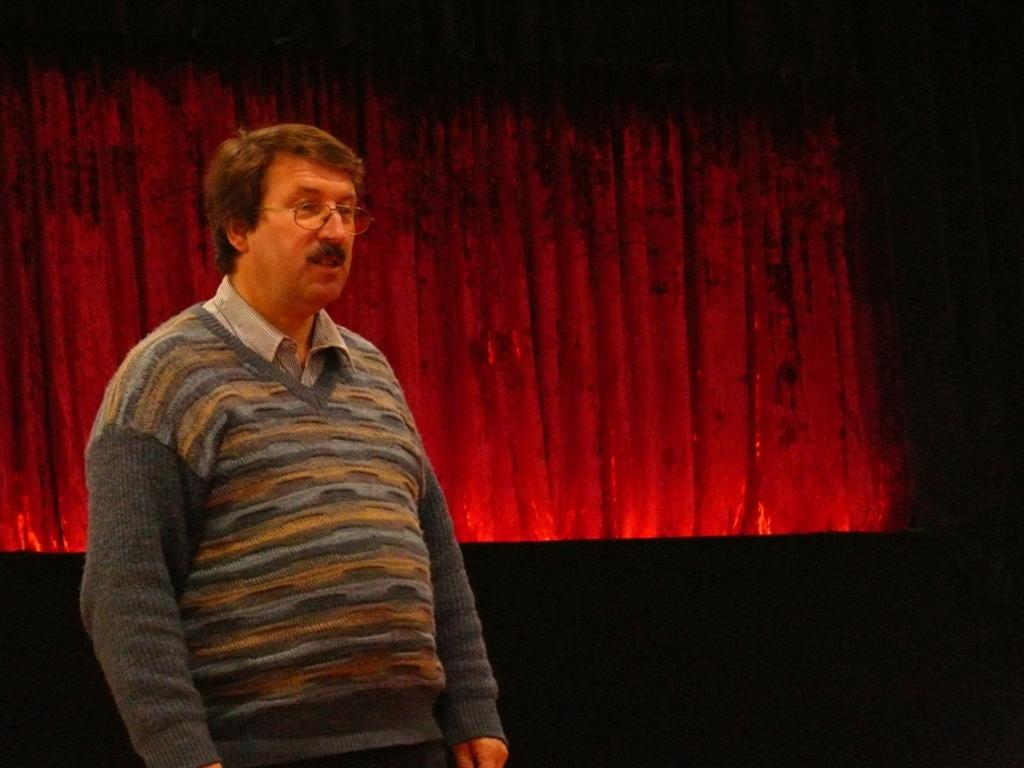Who is present in the image? There is a man in the image. Where is the man located in the image? The man is standing on a stage. What can be seen behind the man? There is a red curtain behind the man. What type of house is visible in the image? There is no house present in the image; it features a man standing on a stage with a red curtain behind him. 